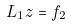<formula> <loc_0><loc_0><loc_500><loc_500>L _ { 1 } z = f _ { 2 }</formula> 